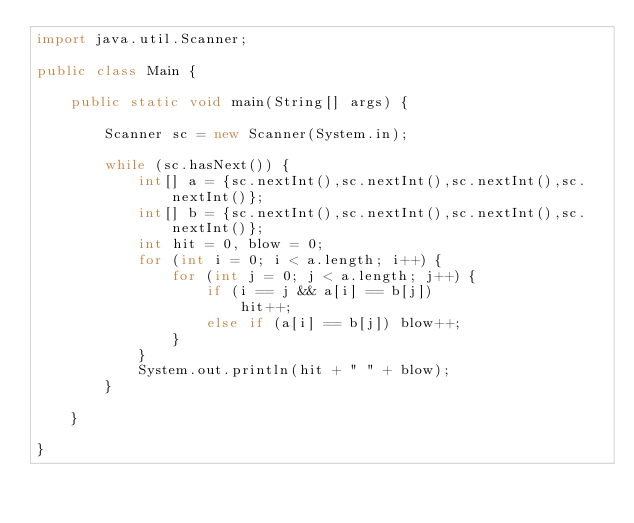<code> <loc_0><loc_0><loc_500><loc_500><_Java_>import java.util.Scanner;

public class Main {

	public static void main(String[] args) {

		Scanner sc = new Scanner(System.in);

		while (sc.hasNext()) {
			int[] a = {sc.nextInt(),sc.nextInt(),sc.nextInt(),sc.nextInt()};
			int[] b = {sc.nextInt(),sc.nextInt(),sc.nextInt(),sc.nextInt()};
			int hit = 0, blow = 0;
			for (int i = 0; i < a.length; i++) {
				for (int j = 0; j < a.length; j++) {
					if (i == j && a[i] == b[j])
						hit++;
					else if (a[i] == b[j]) blow++;
				}
			}
			System.out.println(hit + " " + blow);
		}

	}

}</code> 